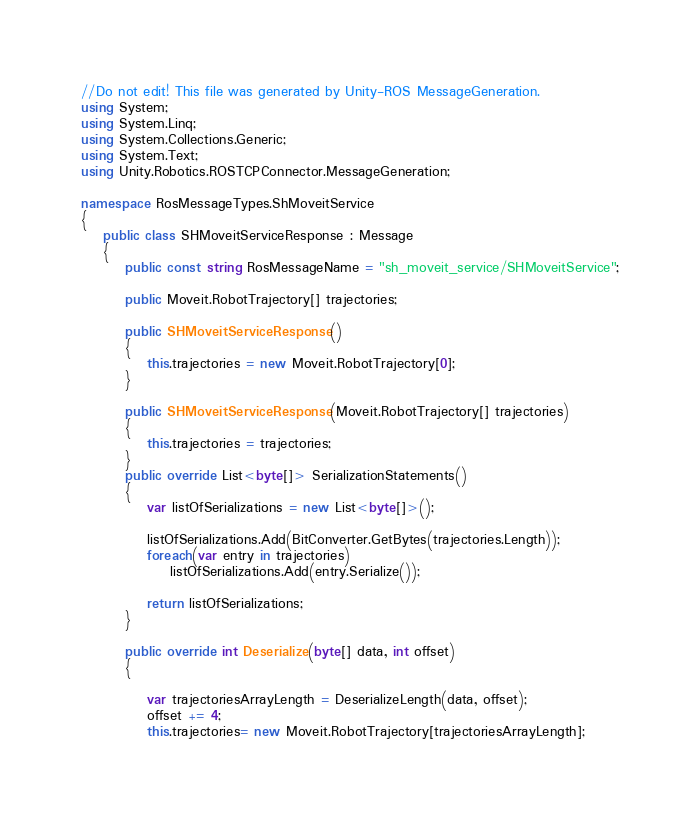Convert code to text. <code><loc_0><loc_0><loc_500><loc_500><_C#_>//Do not edit! This file was generated by Unity-ROS MessageGeneration.
using System;
using System.Linq;
using System.Collections.Generic;
using System.Text;
using Unity.Robotics.ROSTCPConnector.MessageGeneration;

namespace RosMessageTypes.ShMoveitService
{
    public class SHMoveitServiceResponse : Message
    {
        public const string RosMessageName = "sh_moveit_service/SHMoveitService";

        public Moveit.RobotTrajectory[] trajectories;

        public SHMoveitServiceResponse()
        {
            this.trajectories = new Moveit.RobotTrajectory[0];
        }

        public SHMoveitServiceResponse(Moveit.RobotTrajectory[] trajectories)
        {
            this.trajectories = trajectories;
        }
        public override List<byte[]> SerializationStatements()
        {
            var listOfSerializations = new List<byte[]>();
            
            listOfSerializations.Add(BitConverter.GetBytes(trajectories.Length));
            foreach(var entry in trajectories)
                listOfSerializations.Add(entry.Serialize());

            return listOfSerializations;
        }

        public override int Deserialize(byte[] data, int offset)
        {
            
            var trajectoriesArrayLength = DeserializeLength(data, offset);
            offset += 4;
            this.trajectories= new Moveit.RobotTrajectory[trajectoriesArrayLength];</code> 